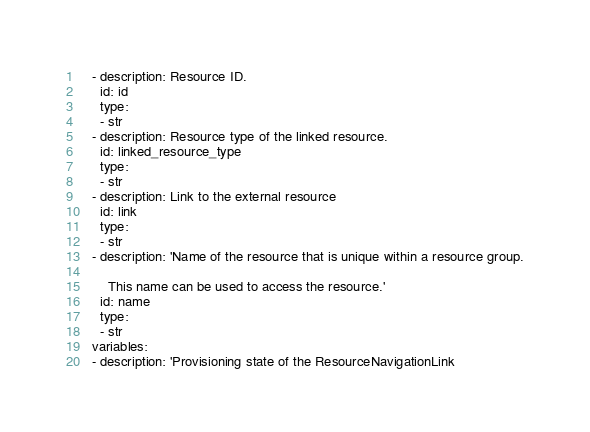Convert code to text. <code><loc_0><loc_0><loc_500><loc_500><_YAML_>    - description: Resource ID.
      id: id
      type:
      - str
    - description: Resource type of the linked resource.
      id: linked_resource_type
      type:
      - str
    - description: Link to the external resource
      id: link
      type:
      - str
    - description: 'Name of the resource that is unique within a resource group.

        This name can be used to access the resource.'
      id: name
      type:
      - str
    variables:
    - description: 'Provisioning state of the ResourceNavigationLink
</code> 